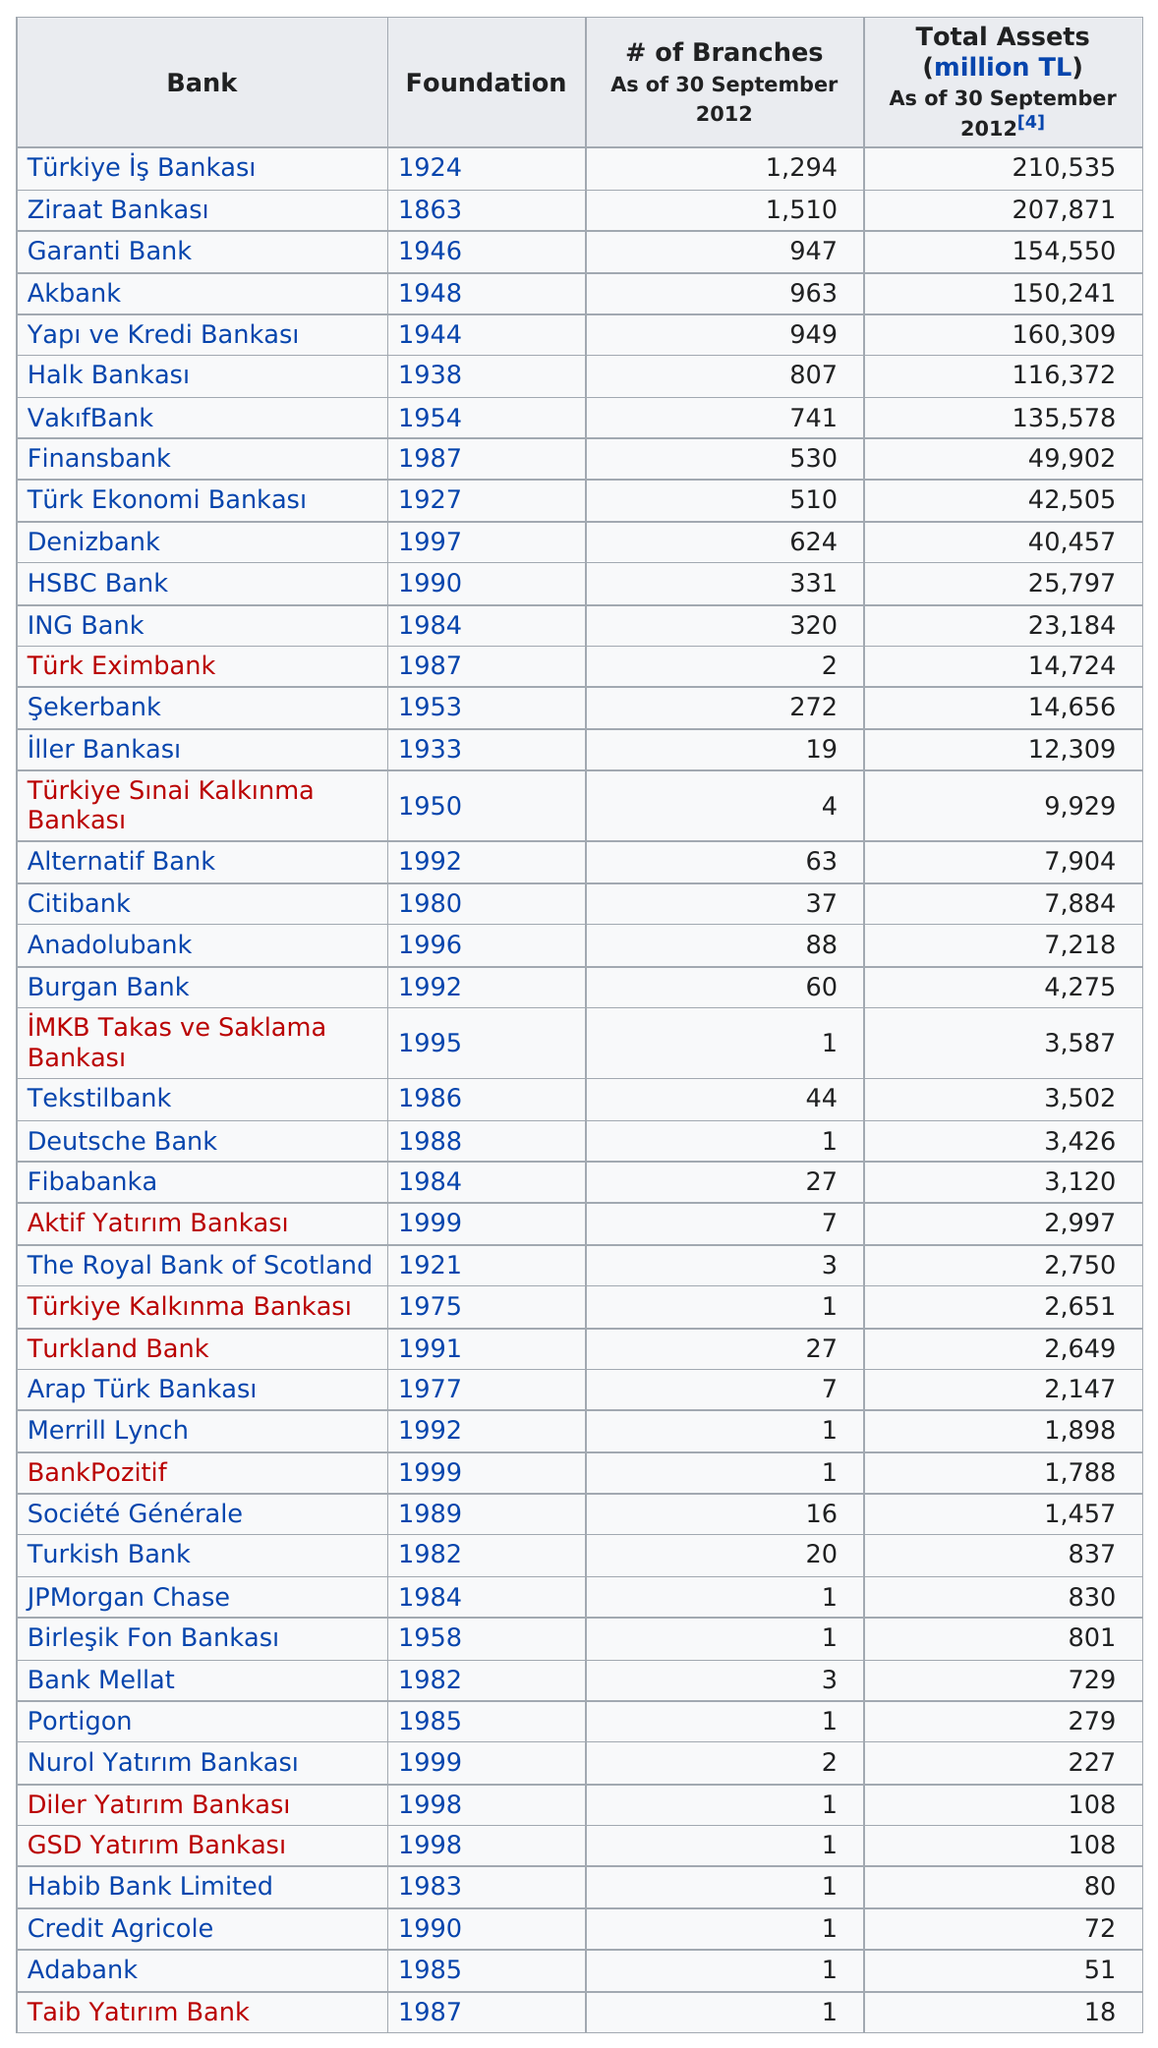Indicate a few pertinent items in this graphic. Credit Agricole has four times as many assets as Taib Yatırım Bank. 